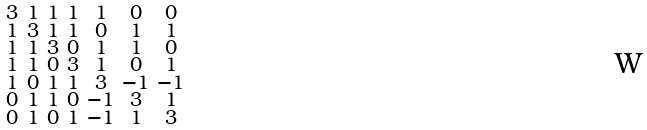Convert formula to latex. <formula><loc_0><loc_0><loc_500><loc_500>\begin{smallmatrix} 3 & 1 & 1 & 1 & 1 & 0 & 0 \\ 1 & 3 & 1 & 1 & 0 & 1 & 1 \\ 1 & 1 & 3 & 0 & 1 & 1 & 0 \\ 1 & 1 & 0 & 3 & 1 & 0 & 1 \\ 1 & 0 & 1 & 1 & 3 & - 1 & - 1 \\ 0 & 1 & 1 & 0 & - 1 & 3 & 1 \\ 0 & 1 & 0 & 1 & - 1 & 1 & 3 \end{smallmatrix}</formula> 